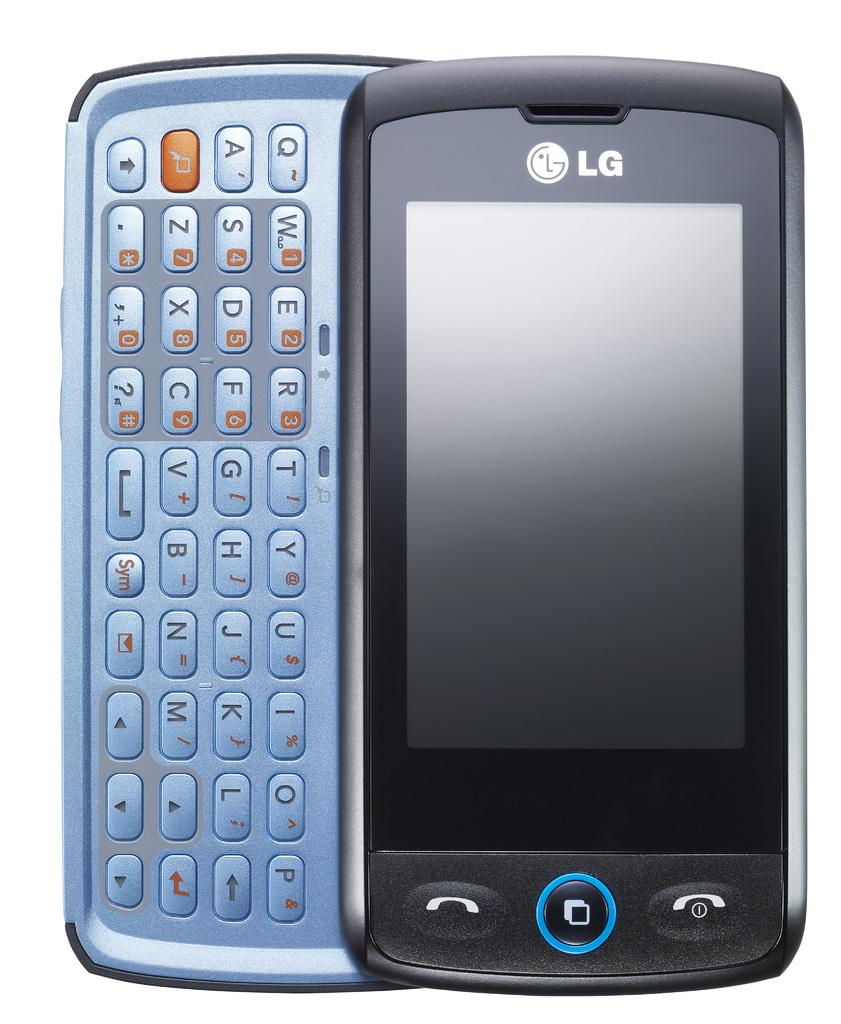<image>
Describe the image concisely. A black LG phone has a blue button at the bottom. 